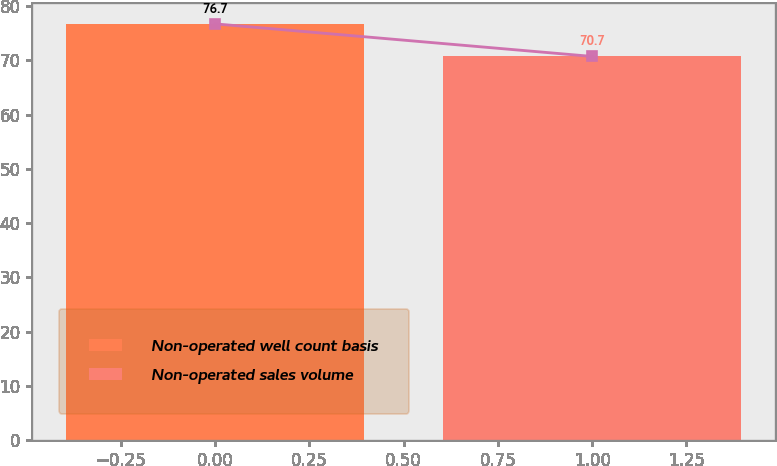Convert chart to OTSL. <chart><loc_0><loc_0><loc_500><loc_500><bar_chart><fcel>Non-operated well count basis<fcel>Non-operated sales volume<nl><fcel>76.7<fcel>70.7<nl></chart> 